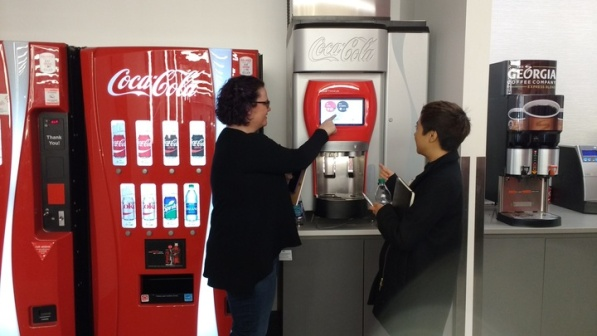Can you tell me more about the technology used in these vending machines? Certainly! The vending machine on the left features a digital touchscreen interface which allows users to interact directly with a graphical display to choose their beverage. This modern approach often includes features like nutritional information, customizable drink options, and electronic payment methods including credit cards and mobile payments. On the right, the older Coca-Cola and Georgia Coffee vending machine uses a traditional mechanical button selection system. This type of machine typically requires cash or coins and offers a more straightforward, tactile interaction where each button corresponds to a specific product. 